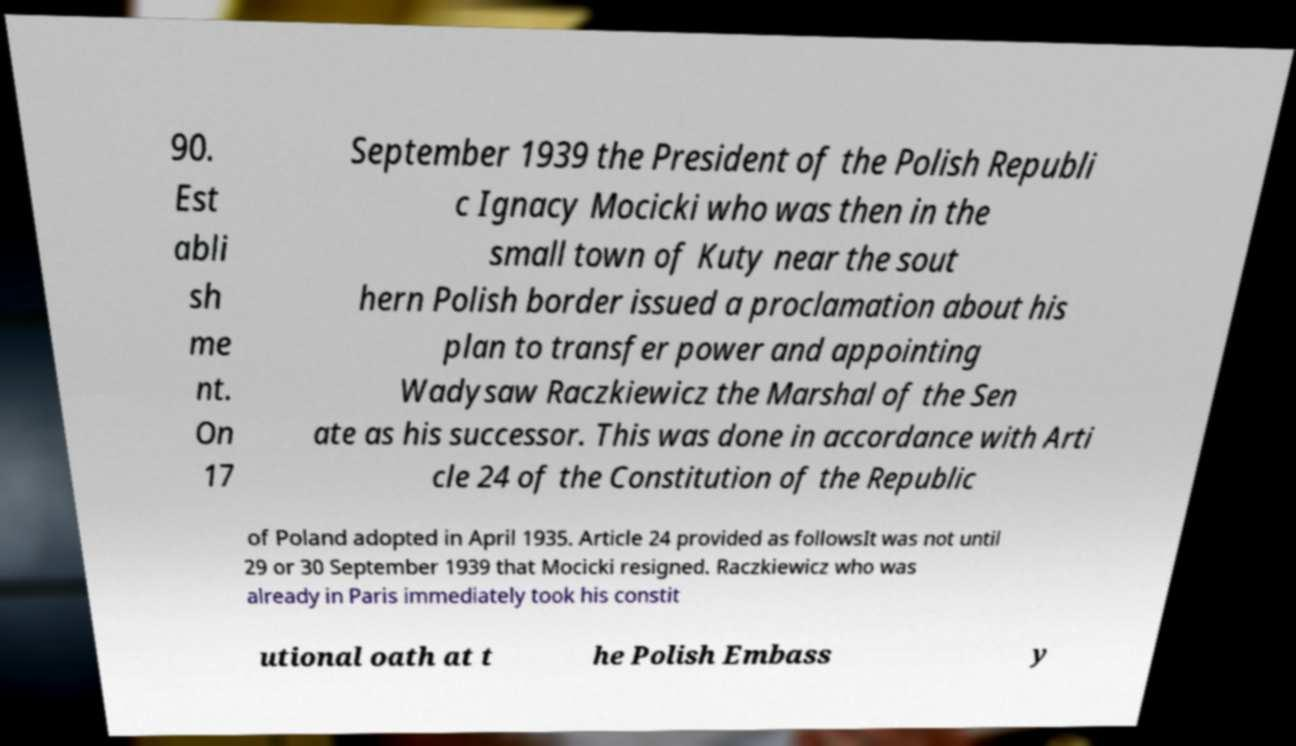What messages or text are displayed in this image? I need them in a readable, typed format. 90. Est abli sh me nt. On 17 September 1939 the President of the Polish Republi c Ignacy Mocicki who was then in the small town of Kuty near the sout hern Polish border issued a proclamation about his plan to transfer power and appointing Wadysaw Raczkiewicz the Marshal of the Sen ate as his successor. This was done in accordance with Arti cle 24 of the Constitution of the Republic of Poland adopted in April 1935. Article 24 provided as followsIt was not until 29 or 30 September 1939 that Mocicki resigned. Raczkiewicz who was already in Paris immediately took his constit utional oath at t he Polish Embass y 